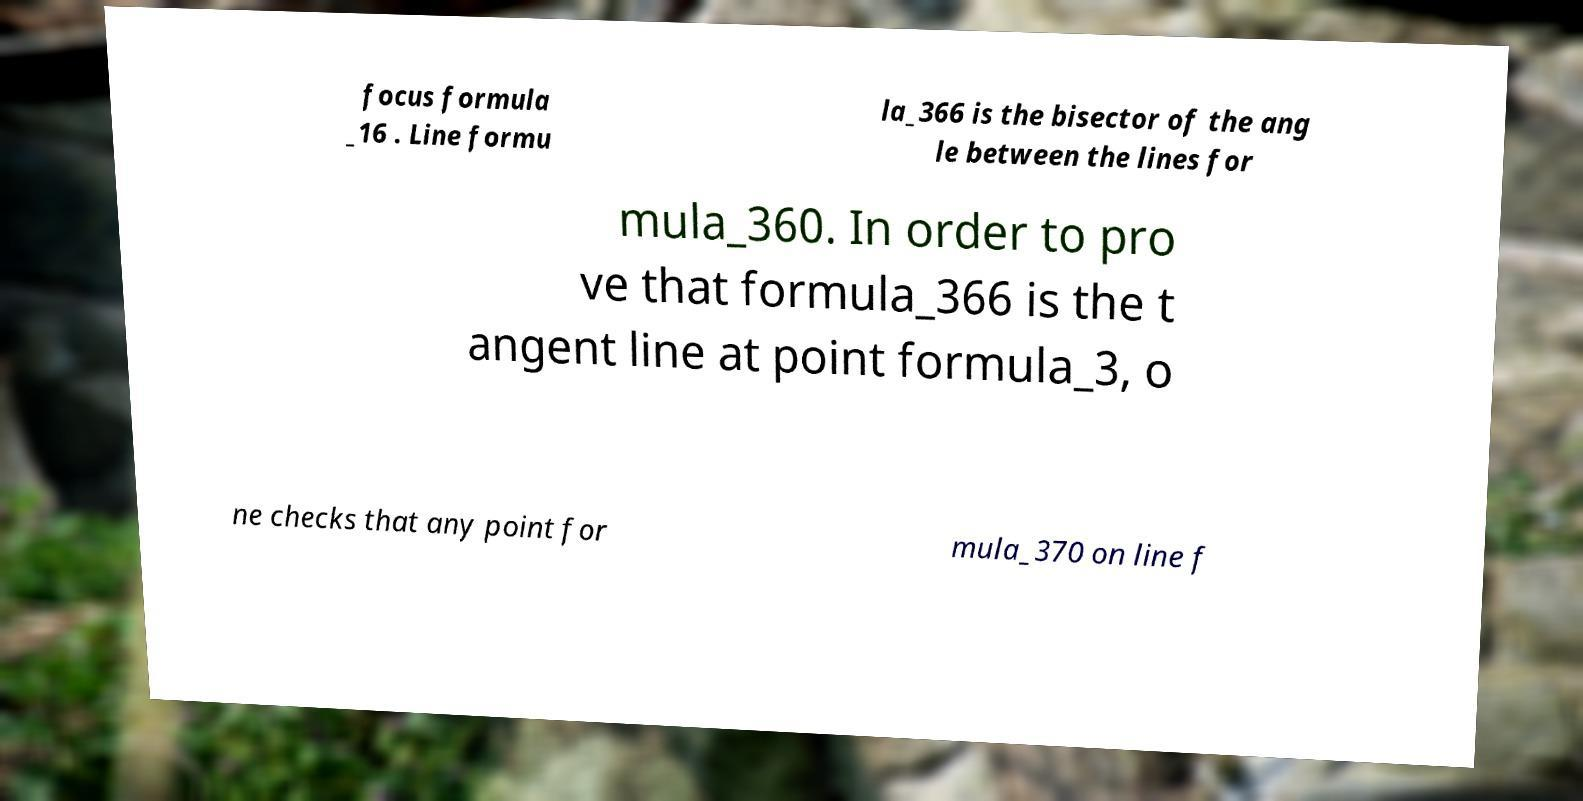Can you accurately transcribe the text from the provided image for me? focus formula _16 . Line formu la_366 is the bisector of the ang le between the lines for mula_360. In order to pro ve that formula_366 is the t angent line at point formula_3, o ne checks that any point for mula_370 on line f 